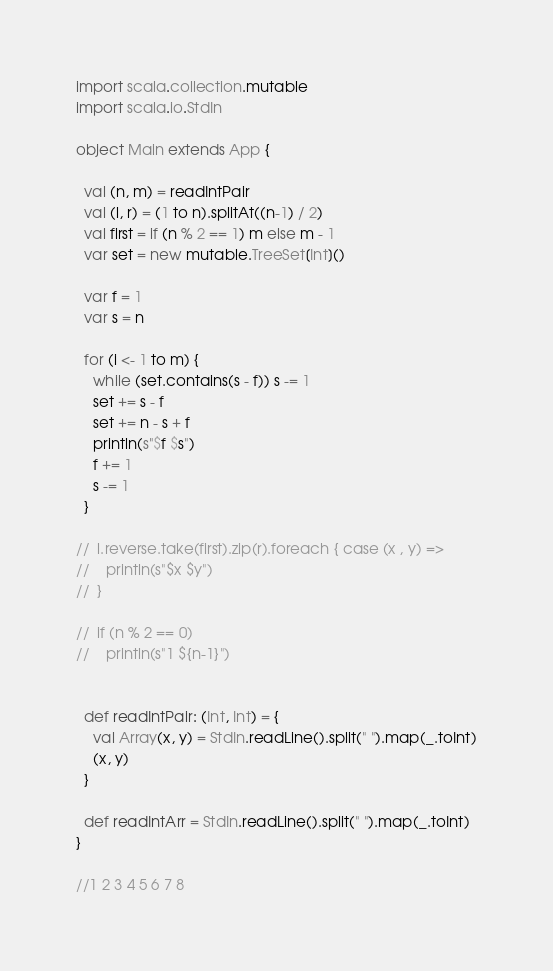Convert code to text. <code><loc_0><loc_0><loc_500><loc_500><_Scala_>import scala.collection.mutable
import scala.io.StdIn

object Main extends App {

  val (n, m) = readIntPair
  val (l, r) = (1 to n).splitAt((n-1) / 2)
  val first = if (n % 2 == 1) m else m - 1
  var set = new mutable.TreeSet[Int]()

  var f = 1
  var s = n

  for (i <- 1 to m) {
    while (set.contains(s - f)) s -= 1
    set += s - f
    set += n - s + f
    println(s"$f $s")
    f += 1
    s -= 1
  }

//  l.reverse.take(first).zip(r).foreach { case (x , y) =>
//    println(s"$x $y")
//  }

//  if (n % 2 == 0)
//    println(s"1 ${n-1}")


  def readIntPair: (Int, Int) = {
    val Array(x, y) = StdIn.readLine().split(" ").map(_.toInt)
    (x, y)
  }

  def readIntArr = StdIn.readLine().split(" ").map(_.toInt)
}

//1 2 3 4 5 6 7 8




</code> 